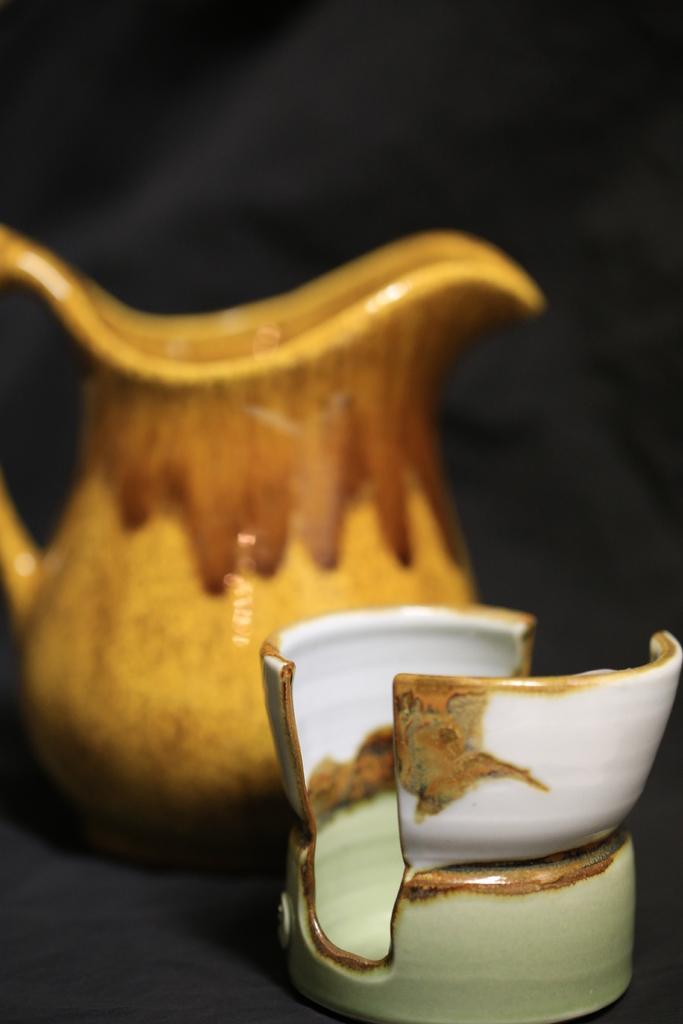Describe this image in one or two sentences. In this image we can see a cup kept on the black color surface. The background of the image is dark and slightly blurred, where we can see a jar kept on the surface. 